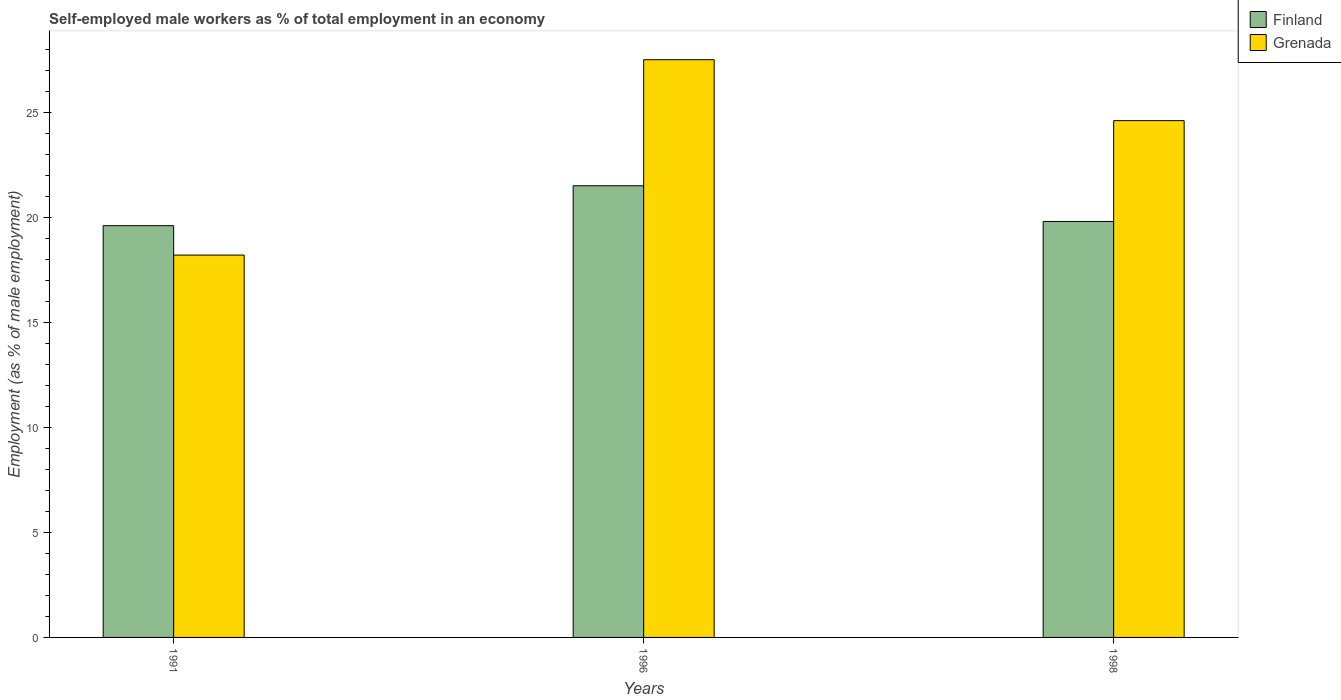How many groups of bars are there?
Your response must be concise. 3. Are the number of bars per tick equal to the number of legend labels?
Ensure brevity in your answer.  Yes. Across all years, what is the maximum percentage of self-employed male workers in Grenada?
Offer a terse response. 27.5. Across all years, what is the minimum percentage of self-employed male workers in Grenada?
Provide a short and direct response. 18.2. In which year was the percentage of self-employed male workers in Grenada minimum?
Offer a very short reply. 1991. What is the total percentage of self-employed male workers in Finland in the graph?
Provide a succinct answer. 60.9. What is the difference between the percentage of self-employed male workers in Finland in 1991 and that in 1996?
Your answer should be very brief. -1.9. What is the difference between the percentage of self-employed male workers in Finland in 1991 and the percentage of self-employed male workers in Grenada in 1996?
Your answer should be compact. -7.9. What is the average percentage of self-employed male workers in Finland per year?
Offer a very short reply. 20.3. In the year 1991, what is the difference between the percentage of self-employed male workers in Finland and percentage of self-employed male workers in Grenada?
Ensure brevity in your answer.  1.4. What is the ratio of the percentage of self-employed male workers in Grenada in 1991 to that in 1998?
Keep it short and to the point. 0.74. Is the percentage of self-employed male workers in Finland in 1996 less than that in 1998?
Your response must be concise. No. Is the difference between the percentage of self-employed male workers in Finland in 1991 and 1998 greater than the difference between the percentage of self-employed male workers in Grenada in 1991 and 1998?
Offer a very short reply. Yes. What is the difference between the highest and the second highest percentage of self-employed male workers in Finland?
Your response must be concise. 1.7. What is the difference between the highest and the lowest percentage of self-employed male workers in Finland?
Your answer should be very brief. 1.9. What does the 2nd bar from the left in 1991 represents?
Make the answer very short. Grenada. What does the 1st bar from the right in 1991 represents?
Offer a terse response. Grenada. How many bars are there?
Offer a terse response. 6. Are all the bars in the graph horizontal?
Ensure brevity in your answer.  No. Are the values on the major ticks of Y-axis written in scientific E-notation?
Offer a terse response. No. Where does the legend appear in the graph?
Make the answer very short. Top right. How are the legend labels stacked?
Make the answer very short. Vertical. What is the title of the graph?
Provide a succinct answer. Self-employed male workers as % of total employment in an economy. What is the label or title of the X-axis?
Ensure brevity in your answer.  Years. What is the label or title of the Y-axis?
Provide a succinct answer. Employment (as % of male employment). What is the Employment (as % of male employment) in Finland in 1991?
Your answer should be very brief. 19.6. What is the Employment (as % of male employment) of Grenada in 1991?
Provide a short and direct response. 18.2. What is the Employment (as % of male employment) in Finland in 1996?
Offer a terse response. 21.5. What is the Employment (as % of male employment) in Grenada in 1996?
Your answer should be very brief. 27.5. What is the Employment (as % of male employment) of Finland in 1998?
Give a very brief answer. 19.8. What is the Employment (as % of male employment) in Grenada in 1998?
Ensure brevity in your answer.  24.6. Across all years, what is the maximum Employment (as % of male employment) in Finland?
Provide a succinct answer. 21.5. Across all years, what is the maximum Employment (as % of male employment) of Grenada?
Your answer should be very brief. 27.5. Across all years, what is the minimum Employment (as % of male employment) of Finland?
Your response must be concise. 19.6. Across all years, what is the minimum Employment (as % of male employment) in Grenada?
Ensure brevity in your answer.  18.2. What is the total Employment (as % of male employment) of Finland in the graph?
Ensure brevity in your answer.  60.9. What is the total Employment (as % of male employment) in Grenada in the graph?
Your answer should be compact. 70.3. What is the difference between the Employment (as % of male employment) in Grenada in 1991 and that in 1996?
Ensure brevity in your answer.  -9.3. What is the difference between the Employment (as % of male employment) in Finland in 1991 and that in 1998?
Give a very brief answer. -0.2. What is the difference between the Employment (as % of male employment) of Grenada in 1991 and that in 1998?
Your answer should be compact. -6.4. What is the difference between the Employment (as % of male employment) of Finland in 1996 and that in 1998?
Provide a short and direct response. 1.7. What is the difference between the Employment (as % of male employment) in Finland in 1996 and the Employment (as % of male employment) in Grenada in 1998?
Provide a succinct answer. -3.1. What is the average Employment (as % of male employment) in Finland per year?
Your answer should be very brief. 20.3. What is the average Employment (as % of male employment) in Grenada per year?
Keep it short and to the point. 23.43. In the year 1991, what is the difference between the Employment (as % of male employment) in Finland and Employment (as % of male employment) in Grenada?
Provide a succinct answer. 1.4. In the year 1996, what is the difference between the Employment (as % of male employment) in Finland and Employment (as % of male employment) in Grenada?
Give a very brief answer. -6. What is the ratio of the Employment (as % of male employment) of Finland in 1991 to that in 1996?
Offer a terse response. 0.91. What is the ratio of the Employment (as % of male employment) in Grenada in 1991 to that in 1996?
Provide a short and direct response. 0.66. What is the ratio of the Employment (as % of male employment) in Finland in 1991 to that in 1998?
Offer a terse response. 0.99. What is the ratio of the Employment (as % of male employment) in Grenada in 1991 to that in 1998?
Provide a short and direct response. 0.74. What is the ratio of the Employment (as % of male employment) in Finland in 1996 to that in 1998?
Make the answer very short. 1.09. What is the ratio of the Employment (as % of male employment) of Grenada in 1996 to that in 1998?
Keep it short and to the point. 1.12. What is the difference between the highest and the lowest Employment (as % of male employment) of Grenada?
Provide a succinct answer. 9.3. 